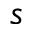Convert formula to latex. <formula><loc_0><loc_0><loc_500><loc_500>s</formula> 